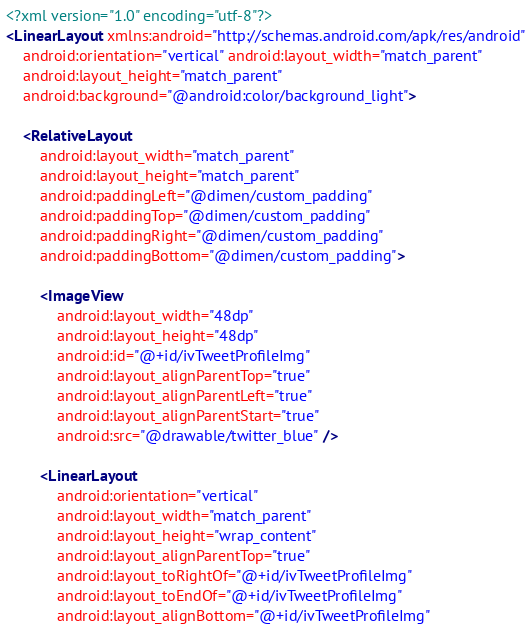<code> <loc_0><loc_0><loc_500><loc_500><_XML_><?xml version="1.0" encoding="utf-8"?>
<LinearLayout xmlns:android="http://schemas.android.com/apk/res/android"
    android:orientation="vertical" android:layout_width="match_parent"
    android:layout_height="match_parent"
    android:background="@android:color/background_light">

    <RelativeLayout
        android:layout_width="match_parent"
        android:layout_height="match_parent"
        android:paddingLeft="@dimen/custom_padding"
        android:paddingTop="@dimen/custom_padding"
        android:paddingRight="@dimen/custom_padding"
        android:paddingBottom="@dimen/custom_padding">

        <ImageView
            android:layout_width="48dp"
            android:layout_height="48dp"
            android:id="@+id/ivTweetProfileImg"
            android:layout_alignParentTop="true"
            android:layout_alignParentLeft="true"
            android:layout_alignParentStart="true"
            android:src="@drawable/twitter_blue" />

        <LinearLayout
            android:orientation="vertical"
            android:layout_width="match_parent"
            android:layout_height="wrap_content"
            android:layout_alignParentTop="true"
            android:layout_toRightOf="@+id/ivTweetProfileImg"
            android:layout_toEndOf="@+id/ivTweetProfileImg"
            android:layout_alignBottom="@+id/ivTweetProfileImg"</code> 